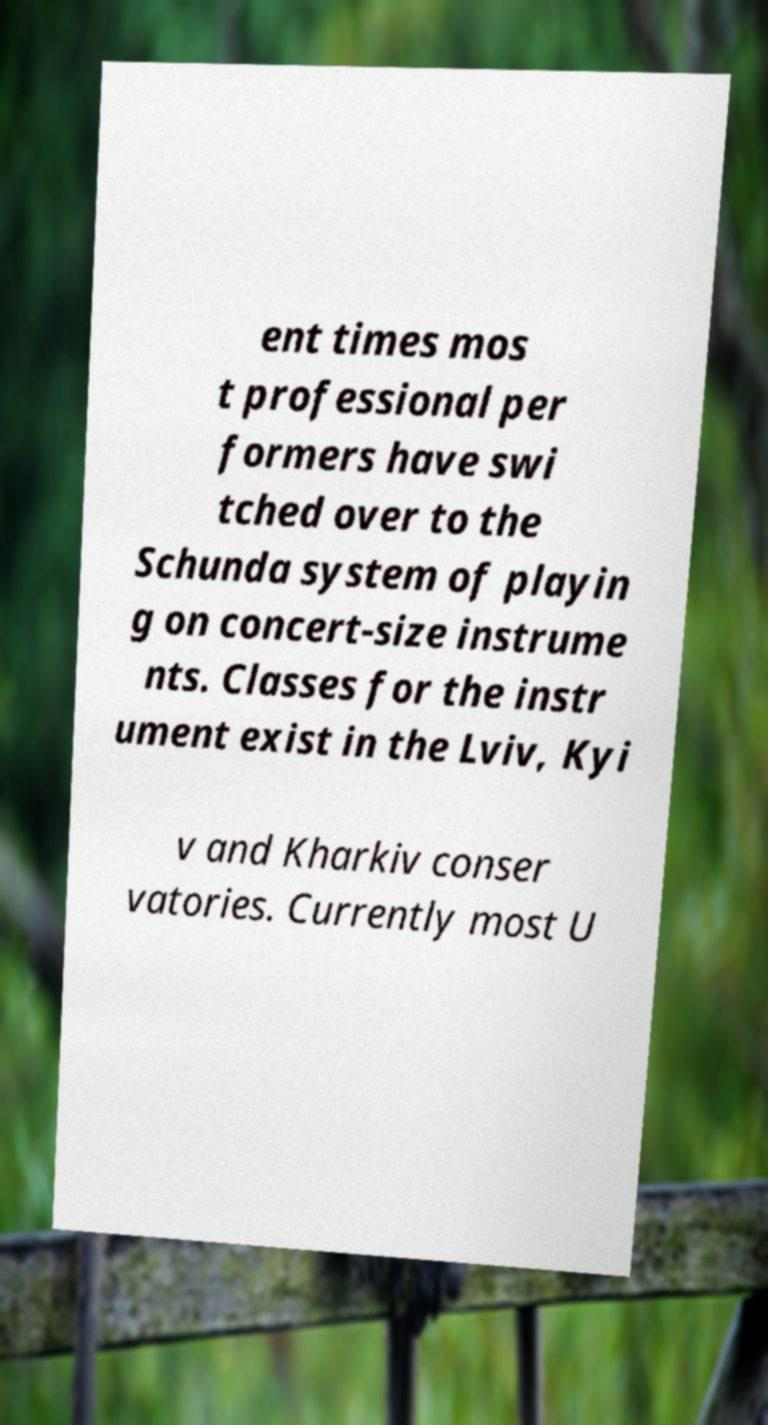I need the written content from this picture converted into text. Can you do that? ent times mos t professional per formers have swi tched over to the Schunda system of playin g on concert-size instrume nts. Classes for the instr ument exist in the Lviv, Kyi v and Kharkiv conser vatories. Currently most U 